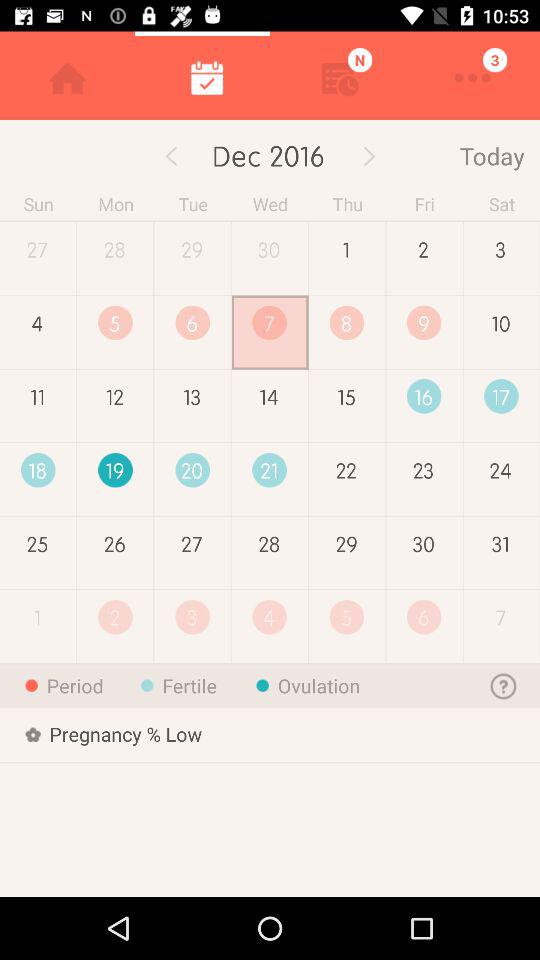What is the pregnancy percentage? The pregnancy percentage is low. 